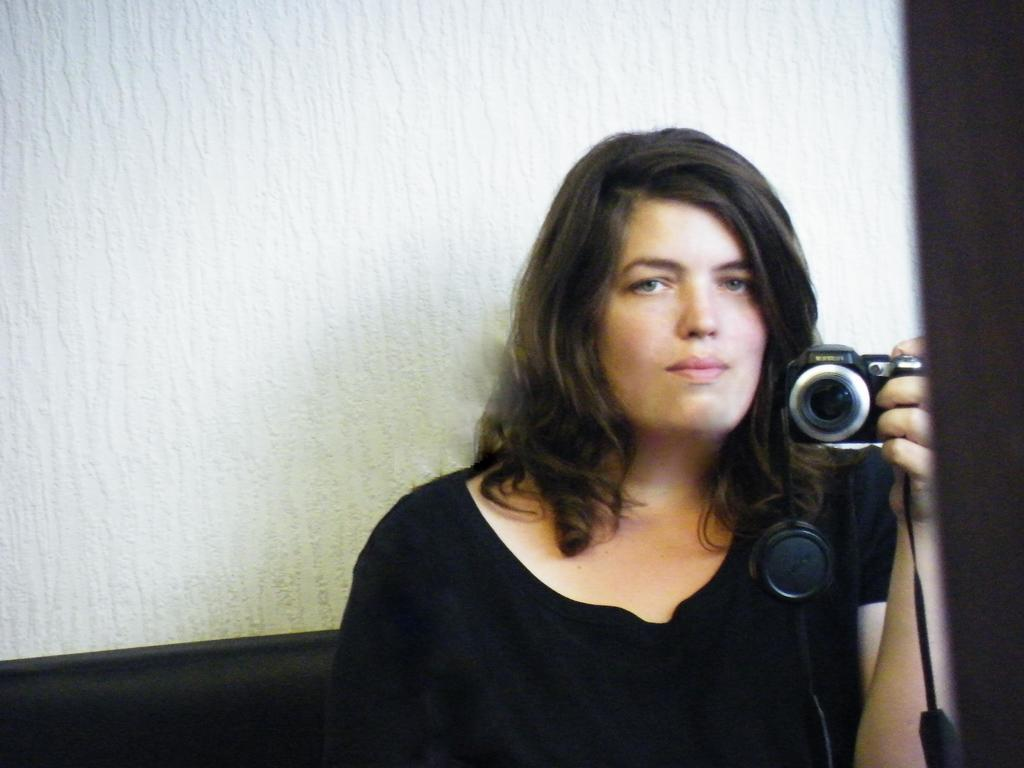Who is the main subject in the image? There is a woman in the image. What is the woman holding in the image? The woman is holding a camera. What is the woman wearing in the image? The woman is wearing a black dress. What can be seen behind the woman in the image? There is a wall behind the woman. What type of leather shoes is the woman wearing in the image? The image does not show the woman wearing any shoes, let alone leather shoes. 